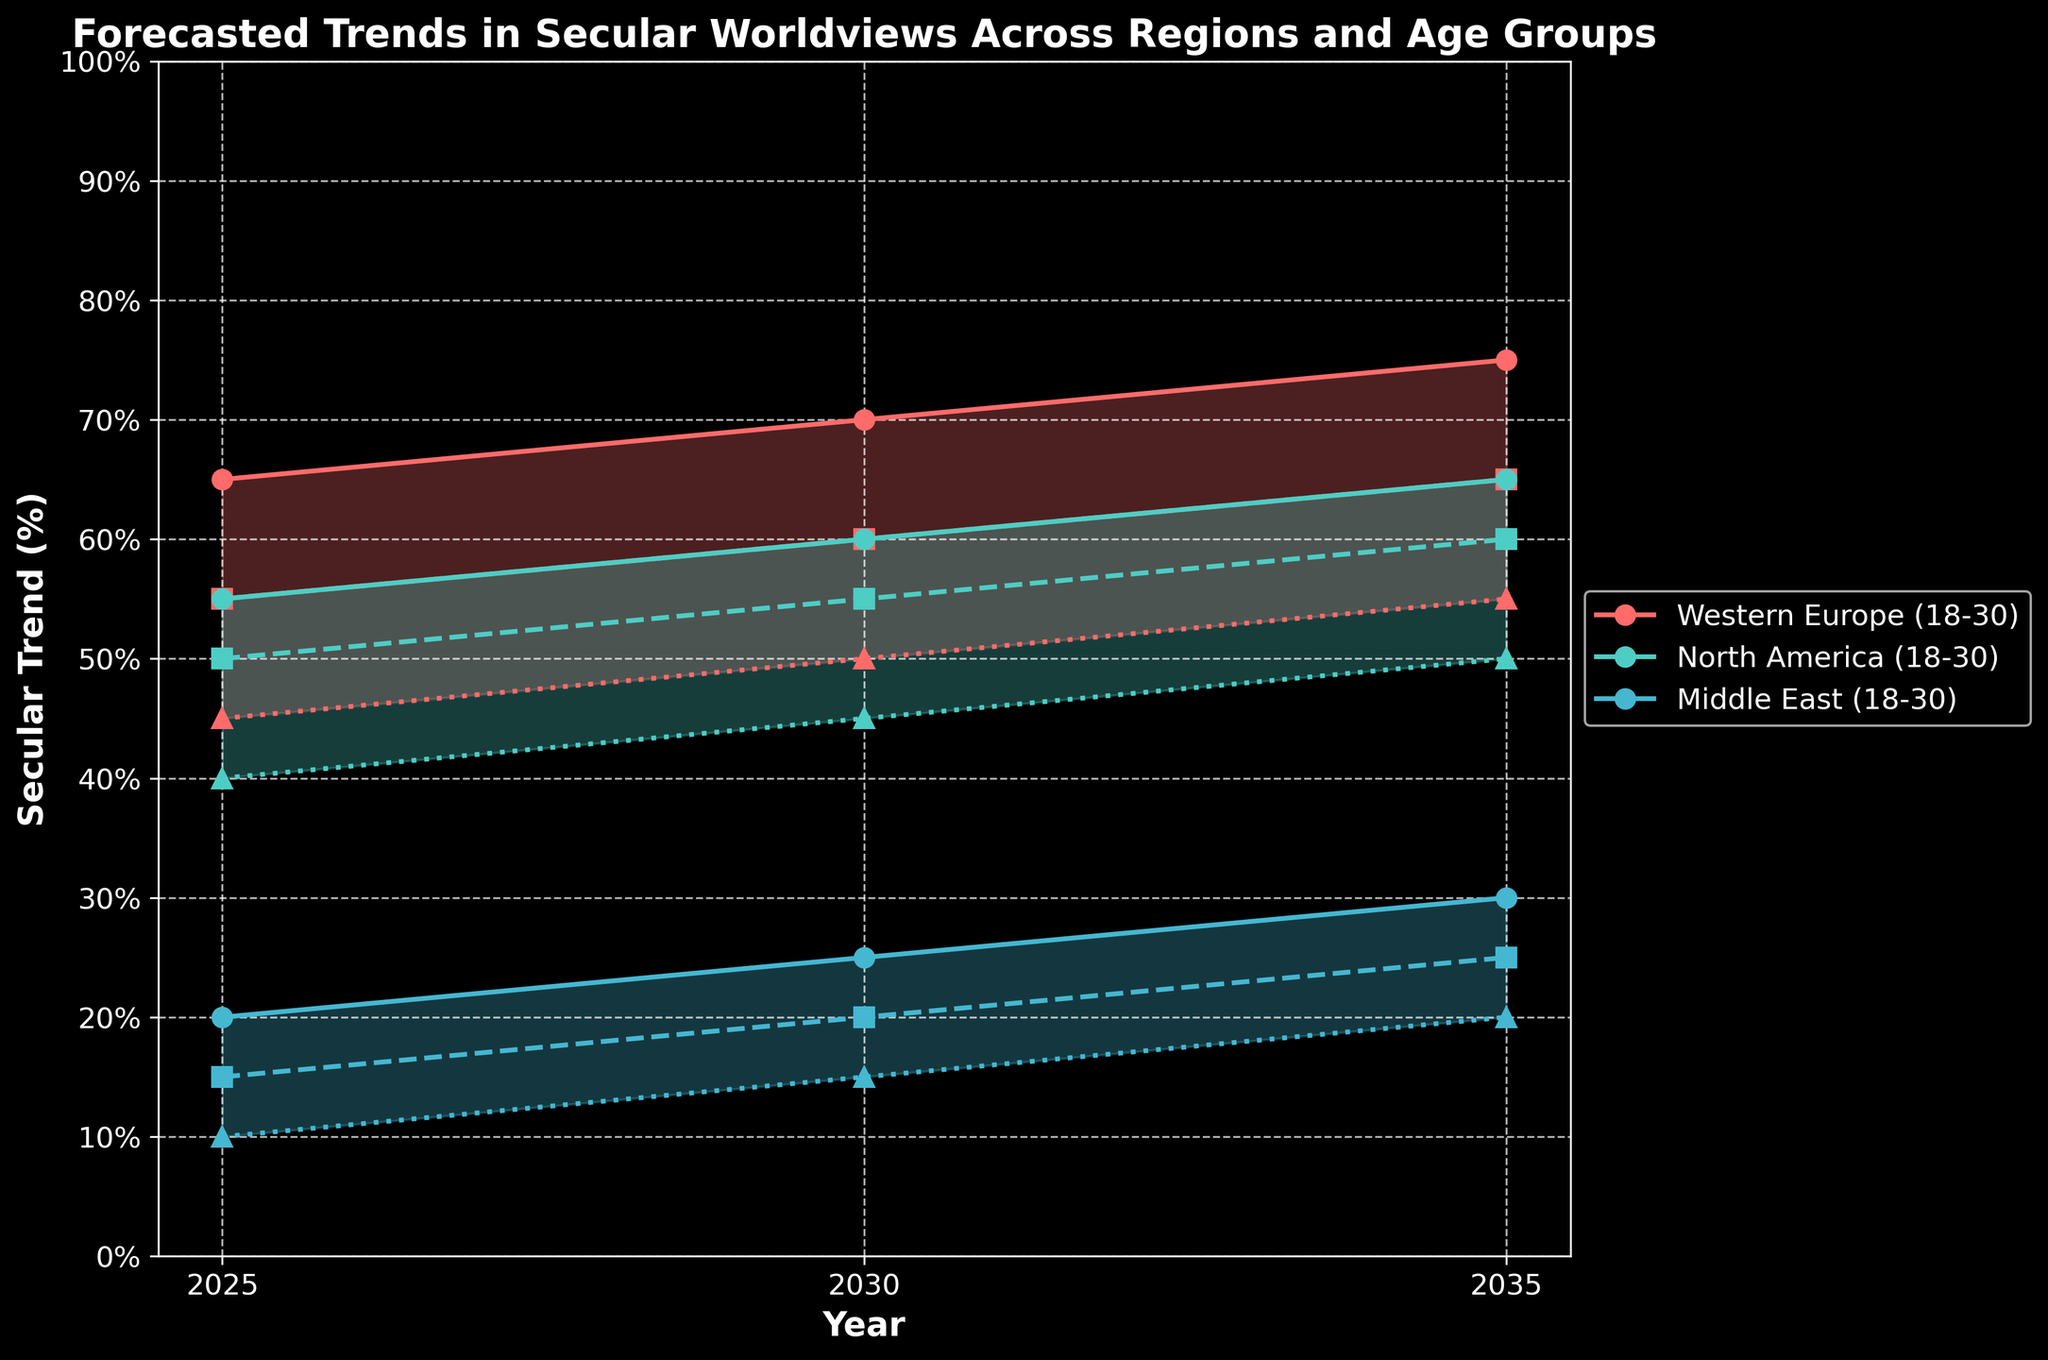What is the title of the figure? The title is typically located at the top of the figure and is often in a larger font than other text on the plot. The figure has the title "Forecasted Trends in Secular Worldviews Across Regions and Age Groups."
Answer: Forecasted Trends in Secular Worldviews Across Regions and Age Groups What is the secular trend percentage for the 18-30 age group in Western Europe in 2030? Locate the plot line for Western Europe with the label 18-30 and find the point where it intersects with the year 2030, then read the corresponding y-axis value. The value is 70%.
Answer: 70% How many years are represented in the figure? The x-axis usually represents years, and we identify the unique years listed which are 2025, 2030, and 2035. This means there are three distinct years shown.
Answer: 3 Compare the secular trend percentage for the 31-50 age group in North America between 2025 and 2035. Find the plotted points or lines for the 31-50 age group in North America at the years 2025 and 2035. For 2025, the secular trend is 50%. For 2035, the secular trend is 60%. There is an increase of 10 percentage points.
Answer: 60% is 10 percentage points higher than 50% What is the difference in secular trend percentage between the 18-30 age group and the 51+ age group in the Middle East in 2025? Locate the secular trend values for the 18-30 age group and the 51+ age group in the Middle East in the year 2025. The values are 20% for 18-30 and 10% for 51+. The difference is 20% - 10% = 10%.
Answer: 10% Which region has the highest secular trend for the 51+ age group in 2035? Compare the secular trends for the 51+ age group across all regions in 2035. Western Europe has 55%, North America has 50%, and the Middle East has 20%. Western Europe has the highest value at 55%.
Answer: Western Europe What is the average secular trend percentage for the 31-50 age group in Western Europe over the three years shown? Find the secular trend values for the 31-50 age group in Western Europe across the years 2025, 2030, and 2035: 55%, 60%, and 65%. Calculate the average: (55 + 60 + 65) / 3 = 60%.
Answer: 60% Between 2025 and 2035 in the Middle East, how did the secular trend percentage for the 31-50 age group change? Identify the secular trend percentages for the 31-50 age group in the Middle East for the years 2025 and 2035, which are 15% and 25%, respectively. The change is 25% - 15% = 10% increase.
Answer: 10% increase 